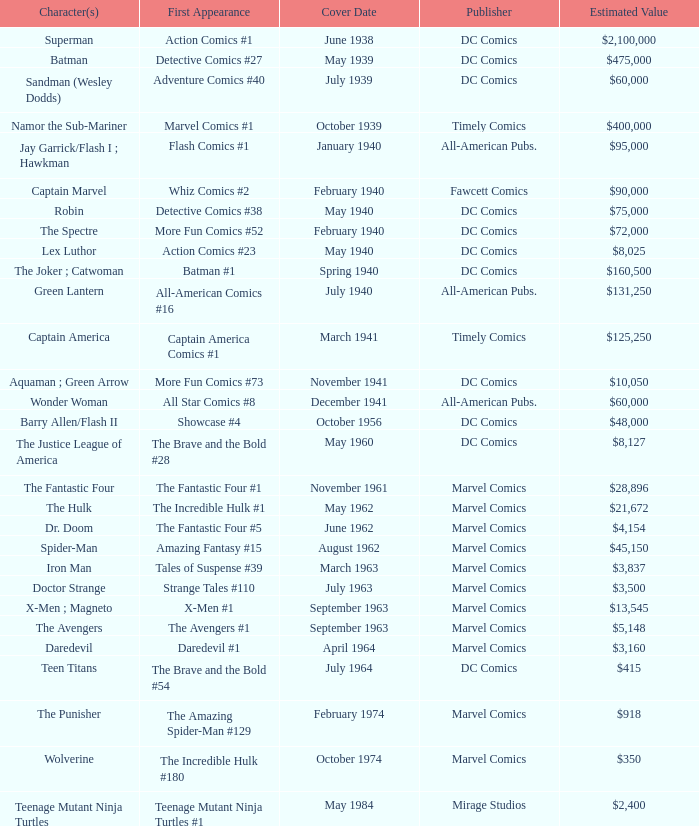What is Action Comics #1's estimated value? $2,100,000. 